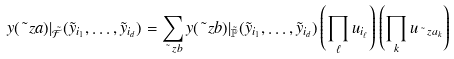Convert formula to latex. <formula><loc_0><loc_0><loc_500><loc_500>y ( \tilde { \ } z a ) | _ { \tilde { \mathcal { F } } } ( \tilde { y } _ { i _ { 1 } } , \dots , \tilde { y } _ { i _ { d } } ) = { \sum _ { \tilde { \ } z b } y ( \tilde { \ } z b ) | _ { \tilde { \mathbb { P } } } ( \tilde { y } _ { i _ { 1 } } , \dots , \tilde { y } _ { i _ { d } } ) } \left ( \prod _ { \ell } u _ { i _ { \ell } } \right ) \left ( \prod _ { k } u _ { \tilde { \ } z a _ { k } } \right )</formula> 